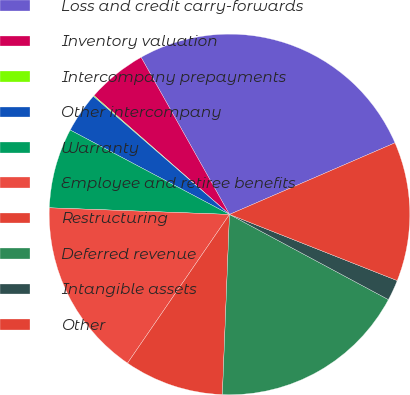Convert chart to OTSL. <chart><loc_0><loc_0><loc_500><loc_500><pie_chart><fcel>Loss and credit carry-forwards<fcel>Inventory valuation<fcel>Intercompany prepayments<fcel>Other intercompany<fcel>Warranty<fcel>Employee and retiree benefits<fcel>Restructuring<fcel>Deferred revenue<fcel>Intangible assets<fcel>Other<nl><fcel>26.66%<fcel>5.39%<fcel>0.08%<fcel>3.62%<fcel>7.17%<fcel>16.02%<fcel>8.94%<fcel>17.8%<fcel>1.85%<fcel>12.48%<nl></chart> 